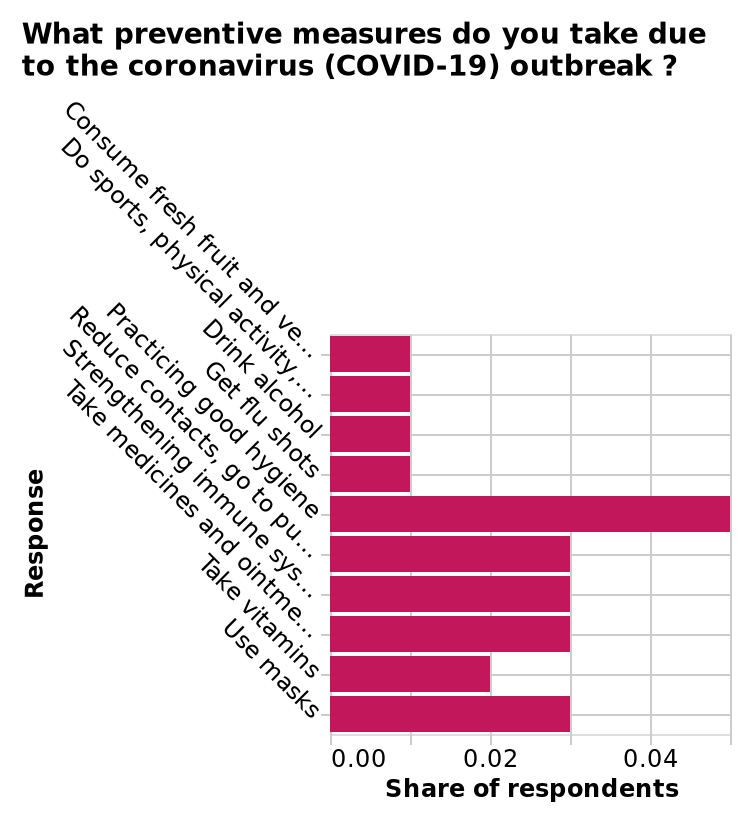<image>
please summary the statistics and relations of the chart The most common preventative measure among respondents was practicing good hygiene. Getting a flu shot was among the lowest reported preventative measure amongst respondents. 